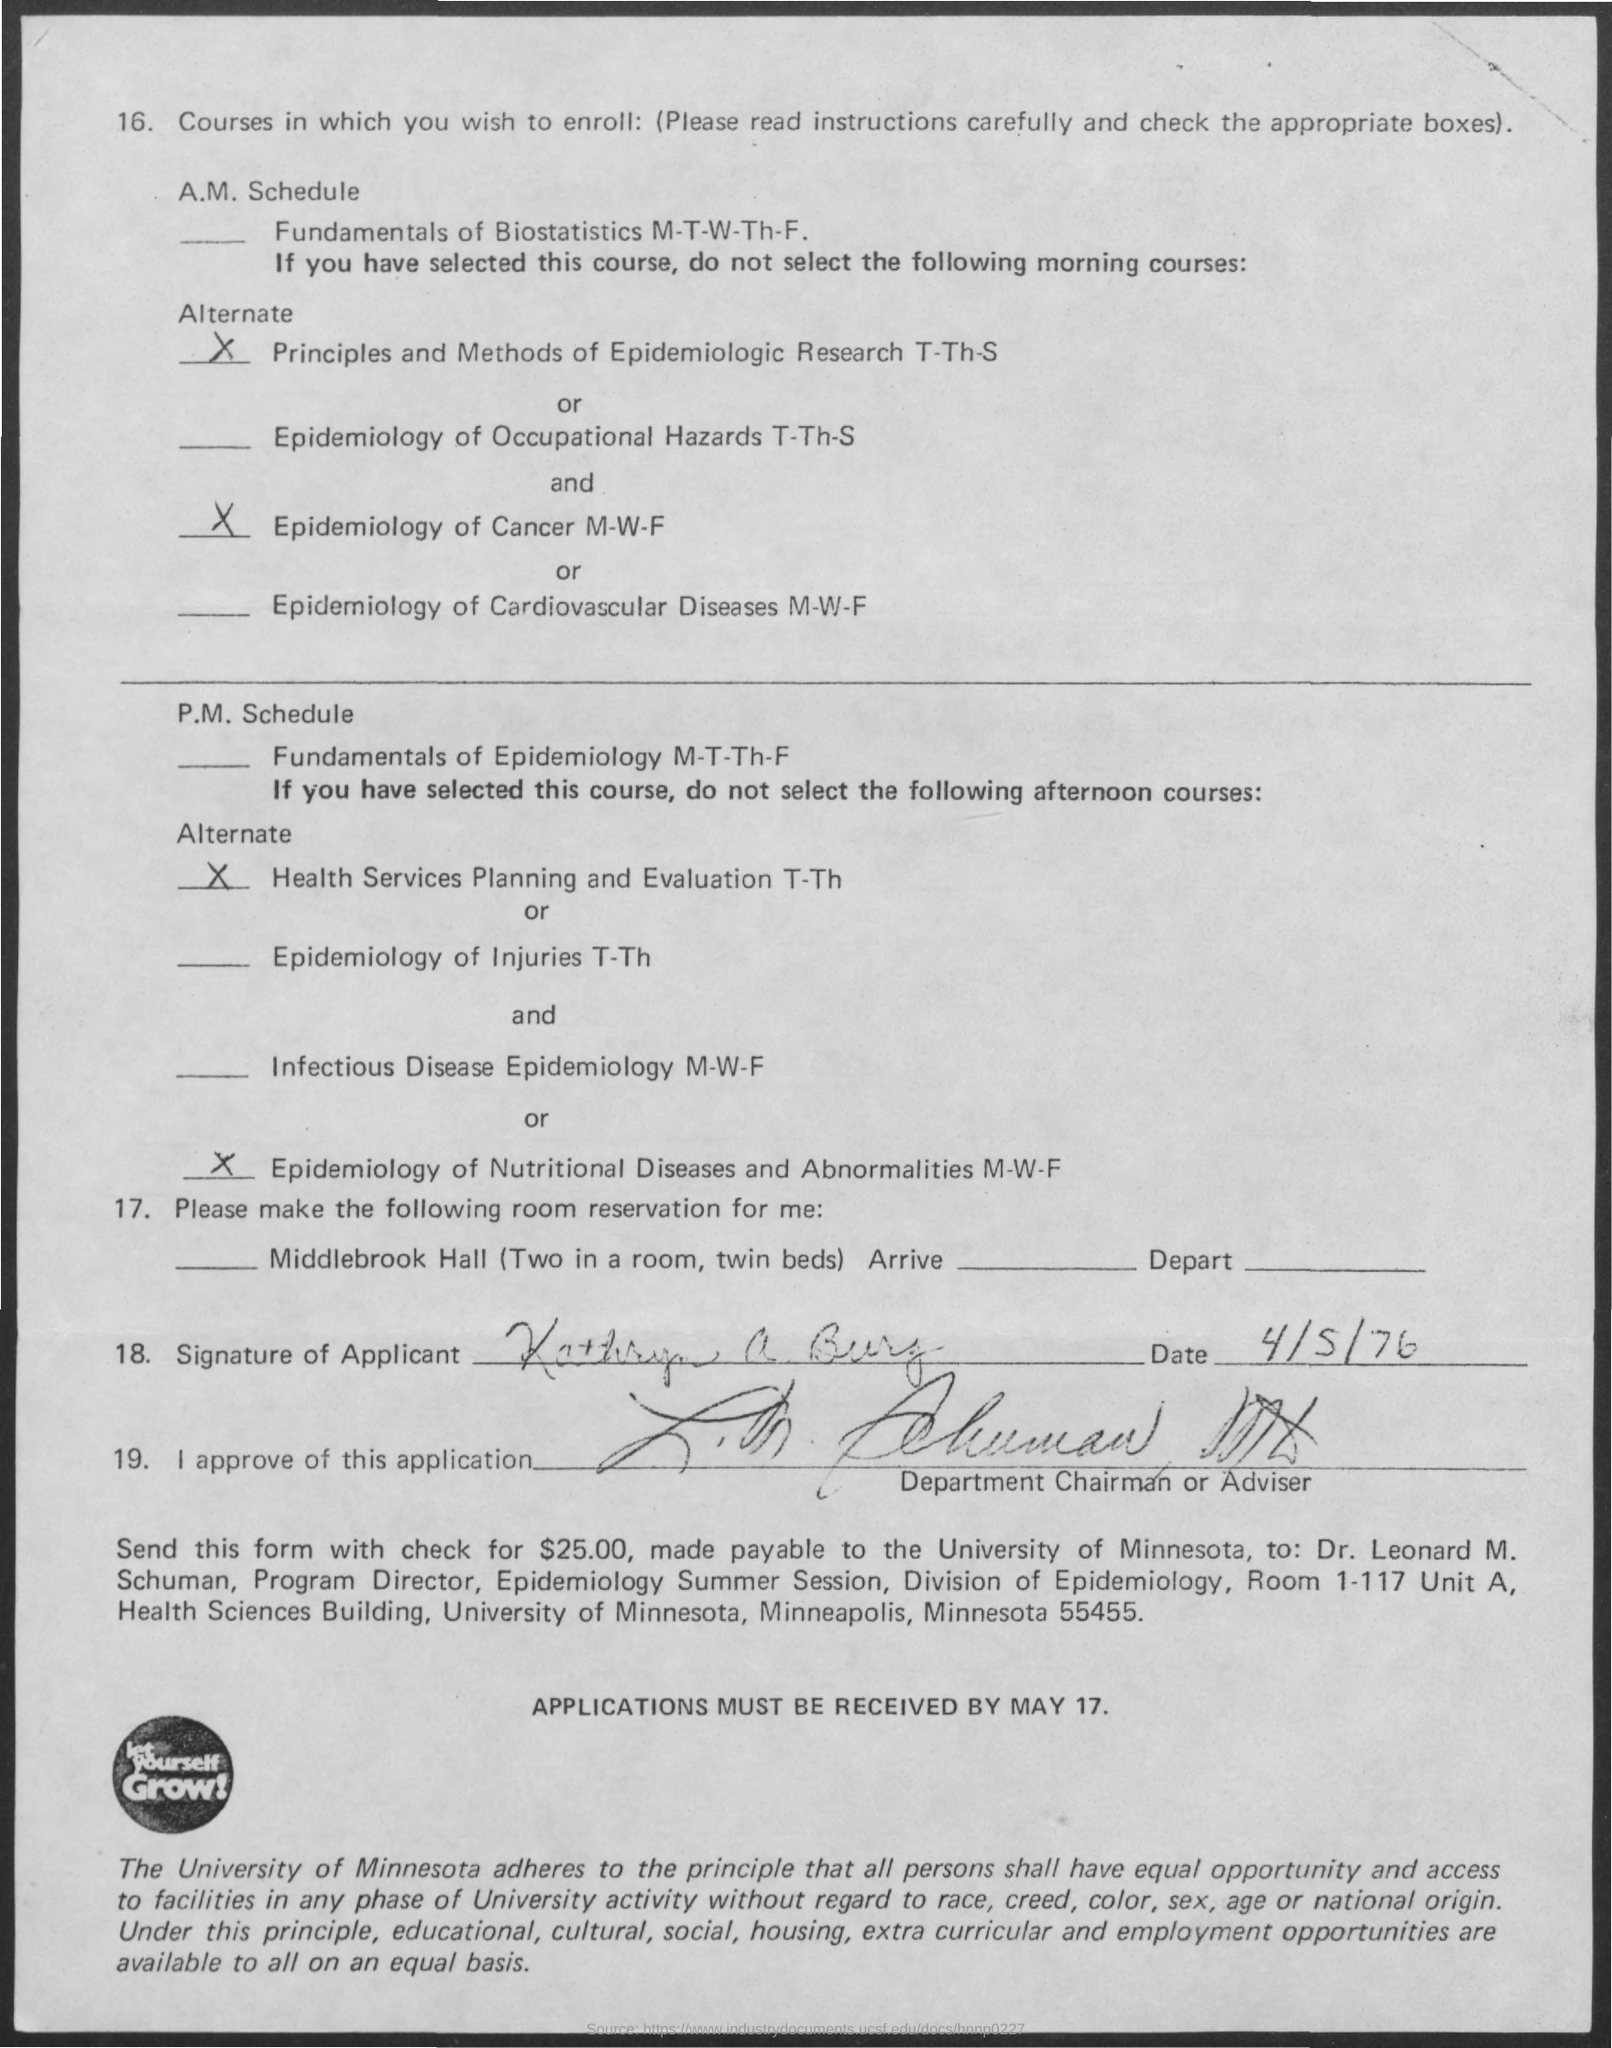What is the date mentioned ?
Offer a very short reply. 4/5/76. How much amount of check has to be sent
Offer a terse response. $25.00. What is the name of the university
Provide a short and direct response. University of minnesota. Who is the program director of epidemiology summer session
Keep it short and to the point. Dr. Leonard M. Schuman. Applications must be received by which date
Give a very brief answer. May 17. 